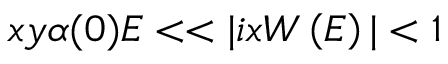Convert formula to latex. <formula><loc_0><loc_0><loc_500><loc_500>x y \alpha ( 0 ) E < < | i x W \left ( E \right ) | < 1</formula> 